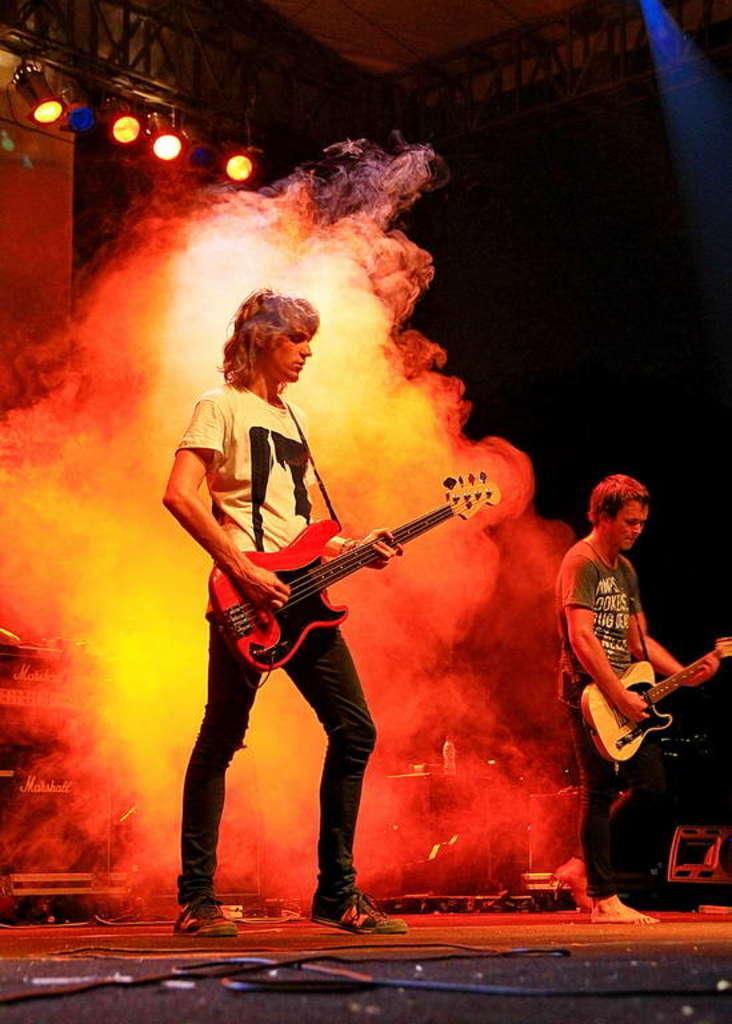Could you give a brief overview of what you see in this image? At the top we can see lights. We can see two men standing on a platform and playing guitar. behind to them there is a smoke. This is a wire. 